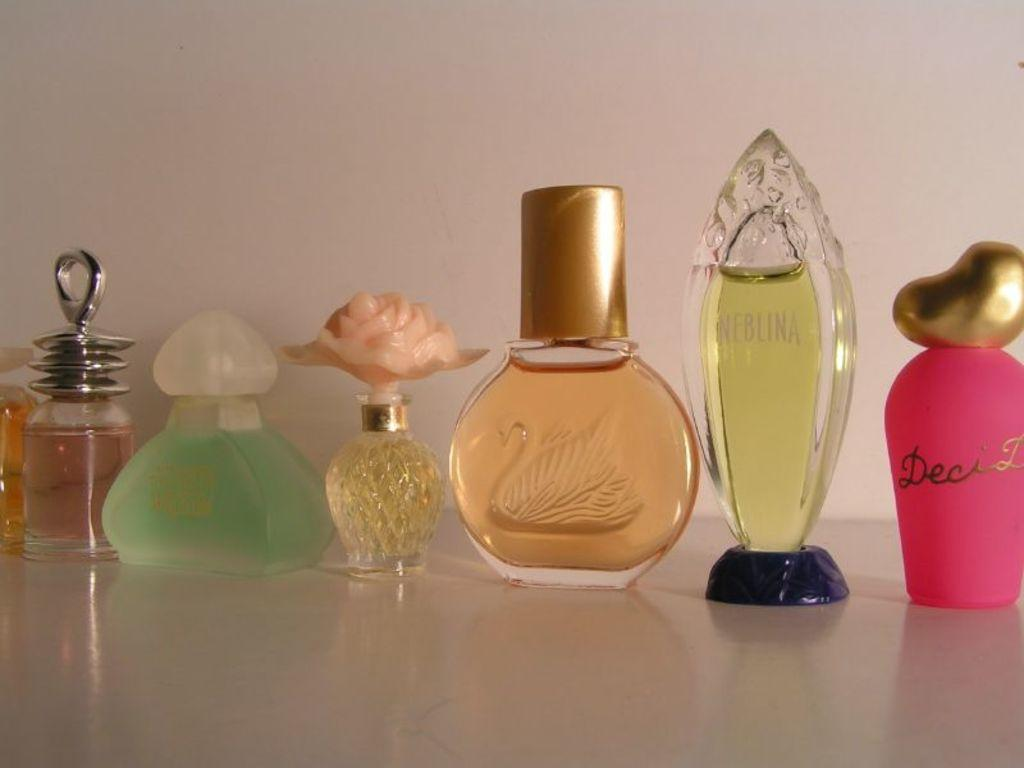What type of objects are in the image? There are perfume bottles in the image. Can you describe the perfume bottles in terms of their shapes? The perfume bottles have various shapes. How about the colors of the perfume bottles? The perfume bottles have various colors. What type of goat can be seen in the image? There is no goat present in the image; it features perfume bottles with various shapes and colors. Is there any indication of a war happening in the image? There is no indication of a war in the image; it features perfume bottles with various shapes and colors. 